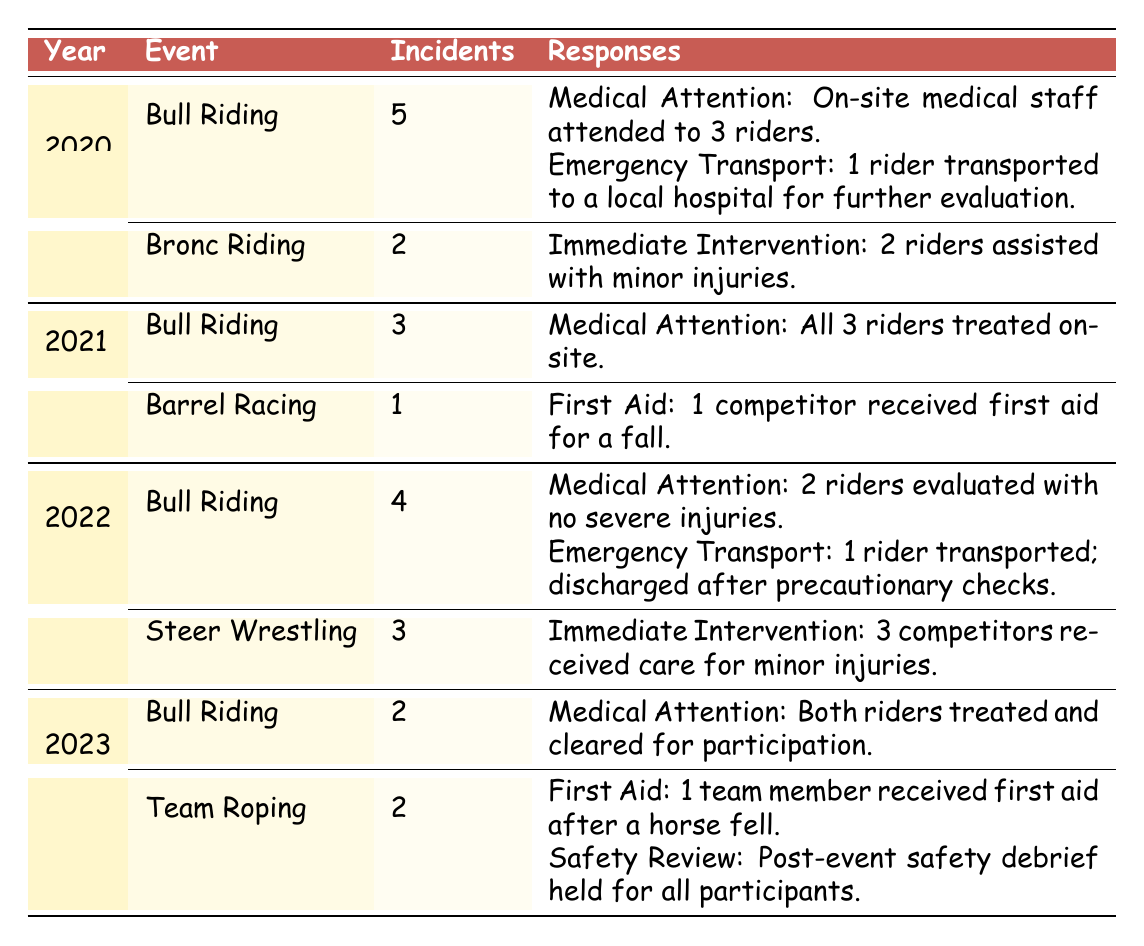What was the total number of safety incidents in Bull Riding over the years 2020 to 2023? From the table, we can see the incident counts for Bull Riding each year: 2020 had 5 incidents, 2021 had 3 incidents, 2022 had 4 incidents, and 2023 had 2 incidents. Adding these together gives a total of 5 + 3 + 4 + 2 = 14 incidents.
Answer: 14 How many safety incidents were reported in Bronc Riding in 2020? The table indicates that in 2020, there were 2 safety incidents reported in Bronc Riding.
Answer: 2 Did any year have more incidents in Bull Riding than in Steer Wrestling? In 2022, Bull Riding had 4 incidents, while Steer Wrestling had 3 incidents. This indicates that Bull Riding had more incidents than Steer Wrestling in that year. Therefore, the answer is yes.
Answer: Yes Which event had the highest number of safety incidents in 2020? The table shows that Bull Riding had 5 incidents, while Bronc Riding had 2 incidents in 2020. This means Bull Riding had the highest number of incidents that year.
Answer: Bull Riding What were the types of responses recorded for the safety incidents in Team Roping in 2023? The table details that in Team Roping in 2023, there were two types of responses: First Aid for 1 team member who received after a horse fell, and a Safety Review which involved a post-event debrief for all participants.
Answer: First Aid and Safety Review How many total safety incidents were there across all events in 2021? In 2021, the table shows Bull Riding with 3 incidents and Barrel Racing with 1 incident. Summing these gives 3 + 1 = 4 total incidents across all events that year.
Answer: 4 Was there an instance in 2020 where a rider was transported to a local hospital? The table states that in 2020 under Bull Riding, 1 rider was indeed transported to a local hospital for further evaluation. Thus, the answer is yes.
Answer: Yes What was the average number of incidents in Bull Riding across the years listed? The counts of incidents for Bull Riding are: 5 (2020), 3 (2021), 4 (2022), and 2 (2023). To calculate the average, we first sum these counts: 5 + 3 + 4 + 2 = 14. Then, since there are 4 years, we divide by 4, giving us 14 / 4 = 3.5.
Answer: 3.5 